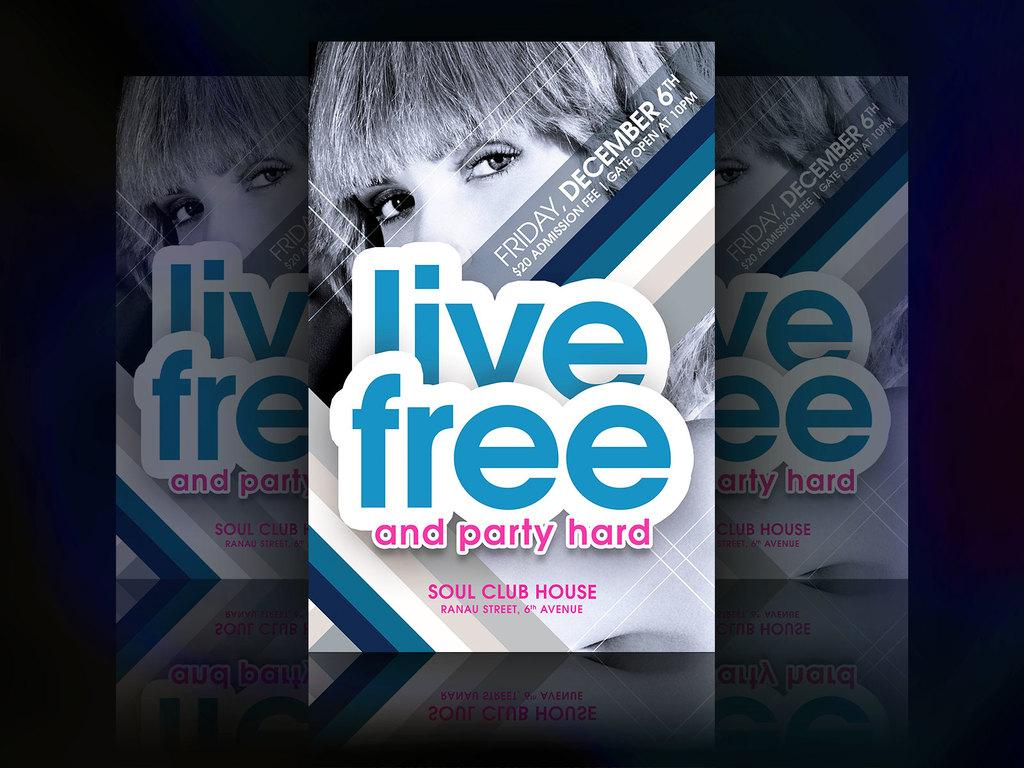Provide a one-sentence caption for the provided image. A poster for a concert called live free and party hard. 